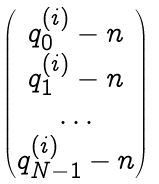<formula> <loc_0><loc_0><loc_500><loc_500>\begin{pmatrix} q _ { 0 } ^ { ( i ) } - n \\ q _ { 1 } ^ { ( i ) } - n \\ \dots \\ q _ { N - 1 } ^ { ( i ) } - n \end{pmatrix}</formula> 